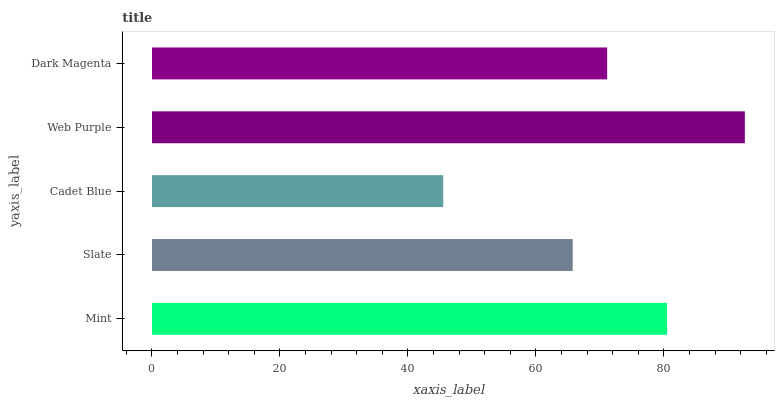Is Cadet Blue the minimum?
Answer yes or no. Yes. Is Web Purple the maximum?
Answer yes or no. Yes. Is Slate the minimum?
Answer yes or no. No. Is Slate the maximum?
Answer yes or no. No. Is Mint greater than Slate?
Answer yes or no. Yes. Is Slate less than Mint?
Answer yes or no. Yes. Is Slate greater than Mint?
Answer yes or no. No. Is Mint less than Slate?
Answer yes or no. No. Is Dark Magenta the high median?
Answer yes or no. Yes. Is Dark Magenta the low median?
Answer yes or no. Yes. Is Slate the high median?
Answer yes or no. No. Is Web Purple the low median?
Answer yes or no. No. 